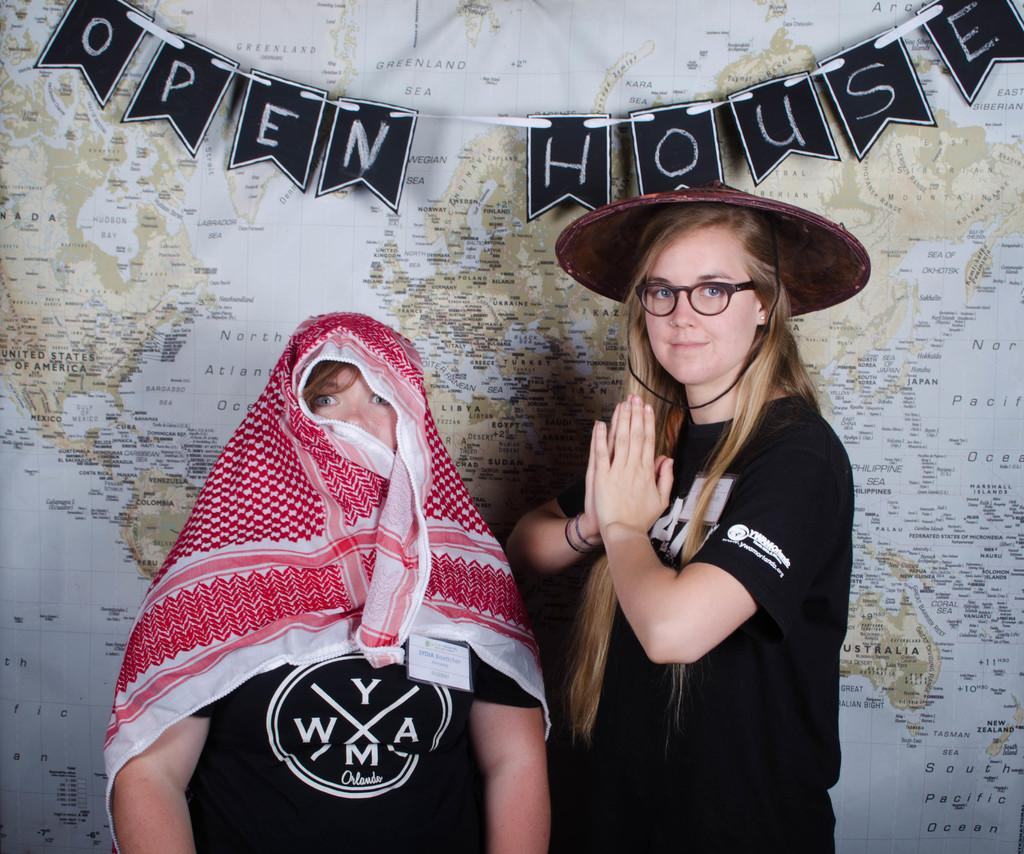How many people are in the image? There are two persons in the image. What are the persons wearing? Both persons are wearing black t-shirts. What are the persons doing in the image? The persons are standing and posing for the picture. What can be seen in the background of the image? There is a map visible in the background of the image. What type of crook can be seen in the image? There is no crook present in the image. What list is visible on the persons' hands in the image? There is no list visible on the persons' hands in the image. 